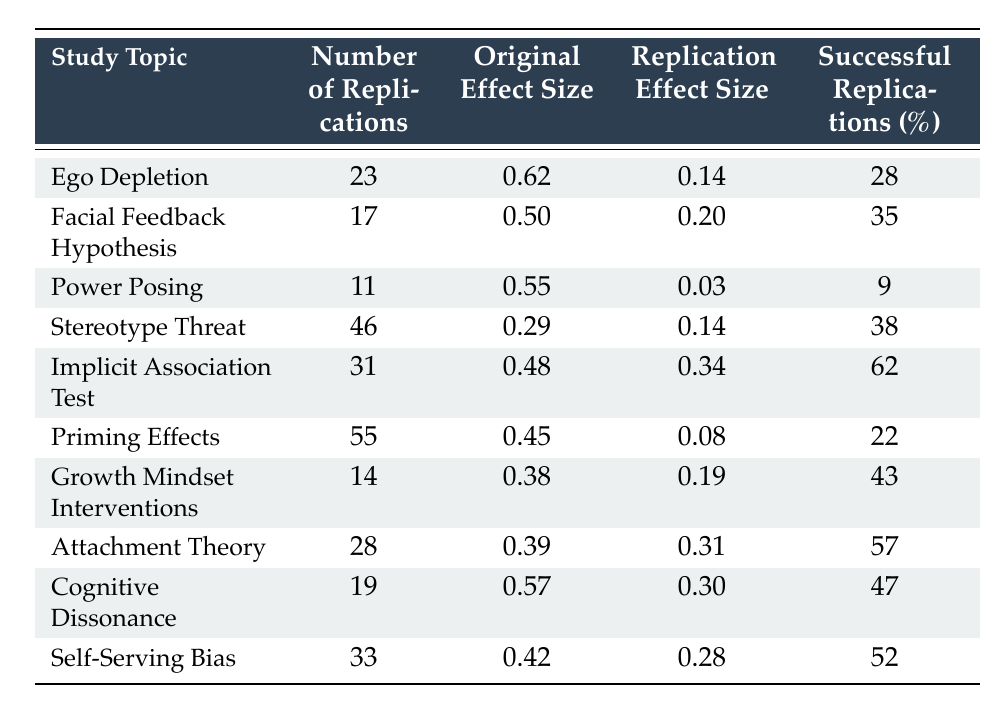What is the original effect size for Ego Depletion? The table lists the original effect size for Ego Depletion specifically under the "Original Effect Size" column. It shows a value of 0.62.
Answer: 0.62 How many successful replications were there for Power Posing? Under the "Successful Replications (%)" column for Power Posing, there is a percentage of 9, indicating that only 9% of the replications were successful.
Answer: 9 What is the average replication effect size for all study topics? To calculate the average replication effect size, sum all the values in the "Replication Effect Size" column (0.14 + 0.20 + 0.03 + 0.14 + 0.34 + 0.08 + 0.19 + 0.31 + 0.30 + 0.28 = 1.65) and divide by the number of studies (10). Therefore, the average is 1.65 / 10 = 0.165.
Answer: 0.165 Are there more replications for the Implicit Association Test than for the Stereotype Threat study? The table shows that the Implicit Association Test has 31 replications, while the Stereotype Threat study has 46. Therefore, the number of replications for the Stereotype Threat study is greater.
Answer: No Which study topic has the highest percentage of successful replications? By examining the "Successful Replications (%)" column, the "Implicit Association Test" has the highest percentage at 62%. This study shows a higher success rate compared to all others.
Answer: Implicit Association Test What is the difference between the original effect size and replication effect size for Cognitive Dissonance? The original effect size for Cognitive Dissonance is 0.57, and the replication effect size is 0.30. To find the difference, subtract the replication effect size from the original effect size: 0.57 - 0.30 = 0.27.
Answer: 0.27 Is the replication effect size for Attachment Theory greater than that of Ego Depletion? For Ego Depletion, the replication effect size is 0.14, and for Attachment Theory, it is 0.31. Since 0.31 is greater than 0.14, the answer is yes.
Answer: Yes What is the total number of replications for studies with successful replication percentages over 50%? The studies with successful replication percentages over 50% are the Implicit Association Test (31), Attachment Theory (28), and Self-Serving Bias (33). Summing these gives: 31 + 28 + 33 = 92.
Answer: 92 